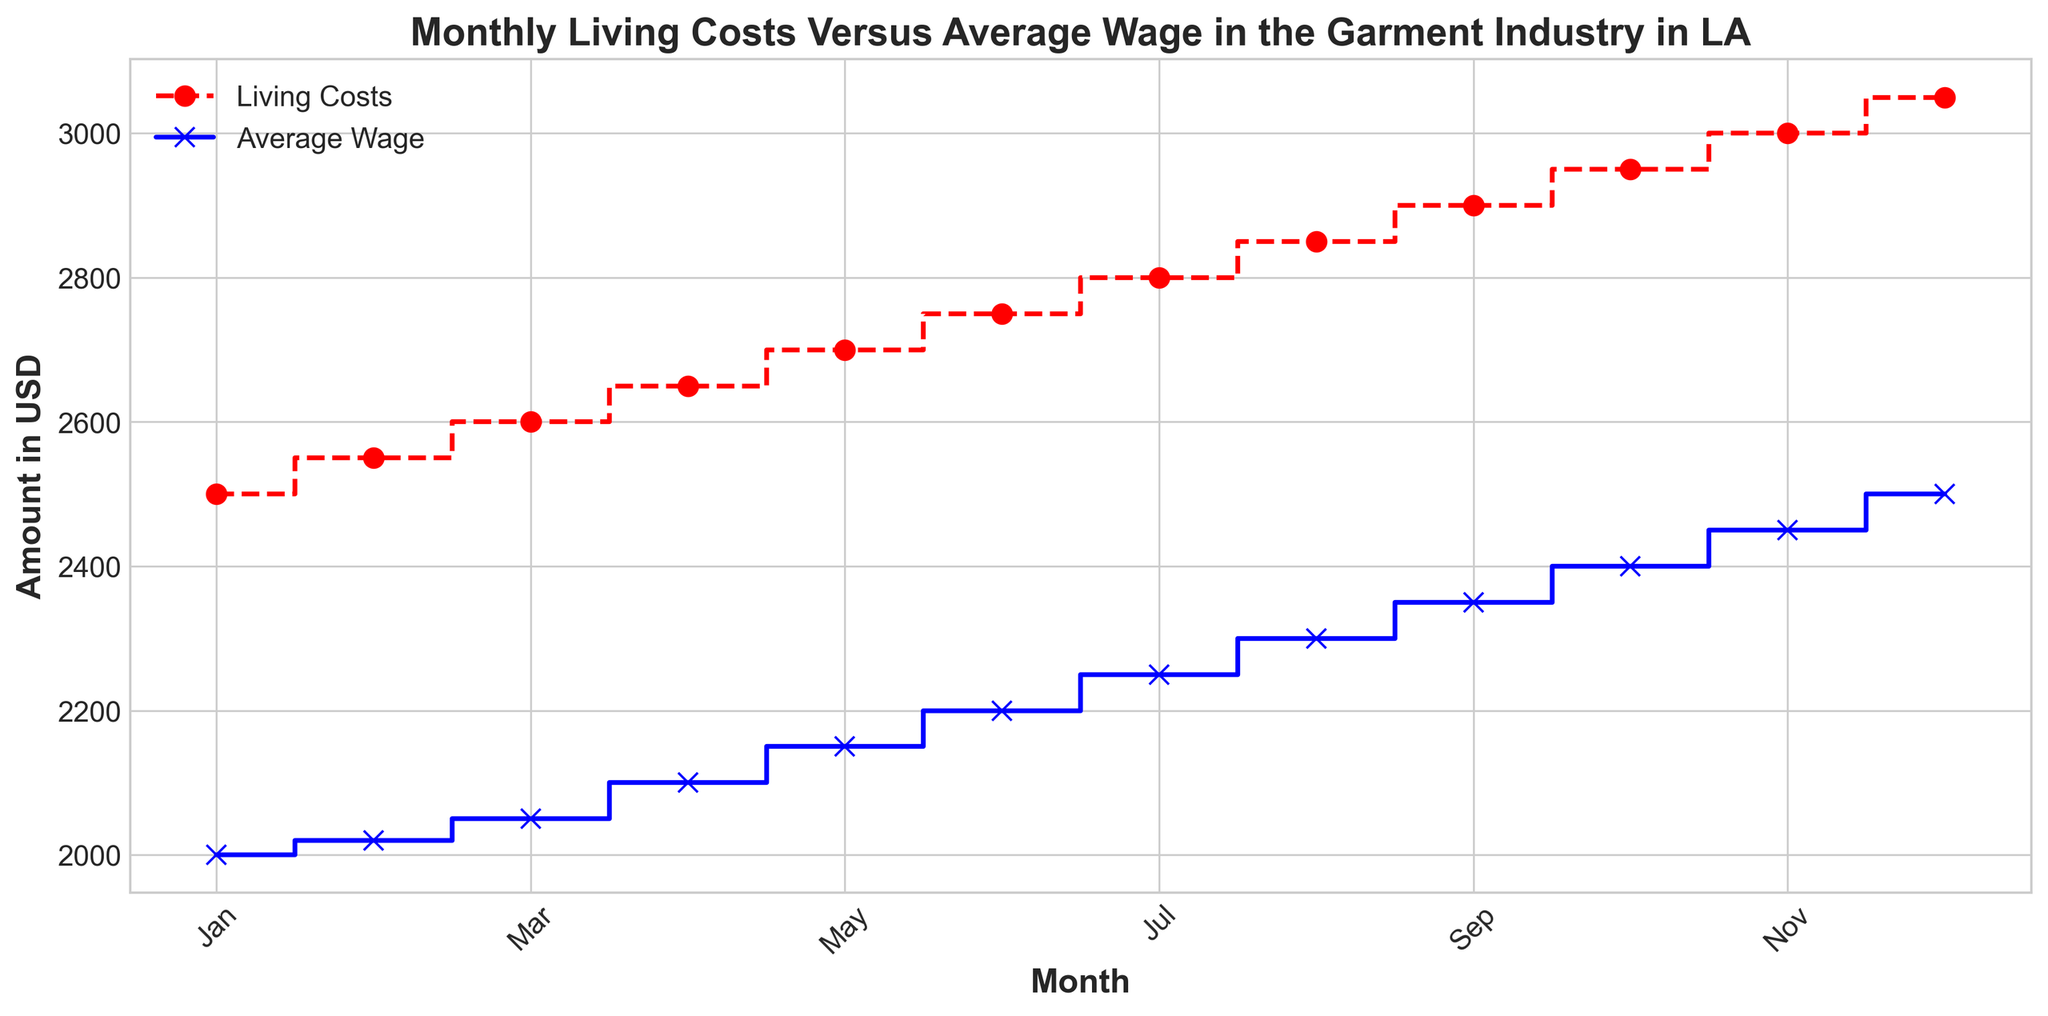What is the difference between living costs and average wage in December? In December, the living costs are $3050 and the average wage is $2500. The difference is $3050 - $2500.
Answer: $550 What is the monthly trend of living costs? The living costs increase each month from January ($2500) to December ($3050). This indicates a continuous upward trend.
Answer: Upward In which month do living costs and average wage have the smallest difference? By observing the figure, the smallest difference occurs in January where living costs are $2500 and average wage is $2000, making the difference $500.
Answer: January Which line on the plot represents the average wage? The average wage is represented by the blue line with solid linestyle and 'x' markers.
Answer: Blue line with 'x' markers By how much does the average wage increase from July to August? From July to August, the average wage increases from $2250 to $2300, so the increase is $2300 - $2250.
Answer: $50 Is there any month where the average wage meets or exceeds the living costs? Reviewing the plot, there is no month where the average wage meets or exceeds the living costs; the average wage is always lower.
Answer: No How does the living cost in June compare to the average wage in June? In June, the living cost is $2750, and the average wage is $2200. The living cost is higher than the average wage by $2750 - $2200.
Answer: $550 higher What is the total yearly increase in living costs? The living costs start at $2500 in January and end at $3050 in December. The total yearly increase is $3050 - $2500.
Answer: $550 Which month sees the highest gap between living costs and average wage? The highest gap can be observed in December where the living costs are $3050 and the average wage is $2500, making the gap $3050 - $2500.
Answer: December 